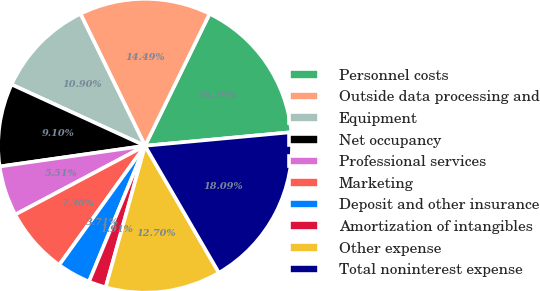<chart> <loc_0><loc_0><loc_500><loc_500><pie_chart><fcel>Personnel costs<fcel>Outside data processing and<fcel>Equipment<fcel>Net occupancy<fcel>Professional services<fcel>Marketing<fcel>Deposit and other insurance<fcel>Amortization of intangibles<fcel>Other expense<fcel>Total noninterest expense<nl><fcel>16.29%<fcel>14.49%<fcel>10.9%<fcel>9.1%<fcel>5.51%<fcel>7.3%<fcel>3.71%<fcel>1.91%<fcel>12.7%<fcel>18.09%<nl></chart> 